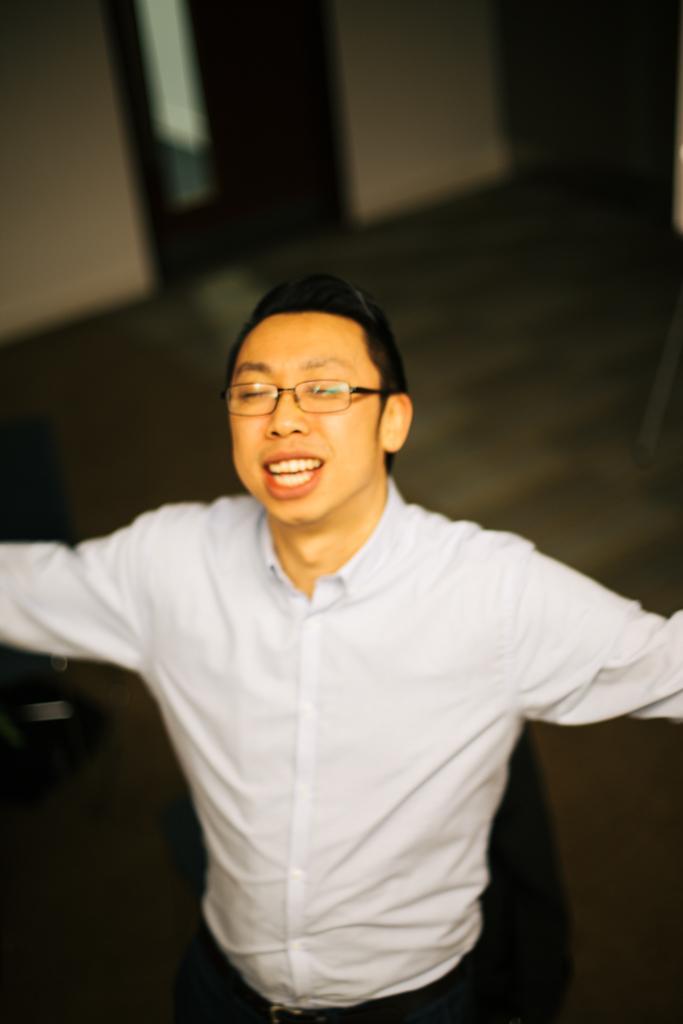Describe this image in one or two sentences. As we can see in the image in the front there is a man wearing white color shirt and spectacles. In the background there is a wall. 